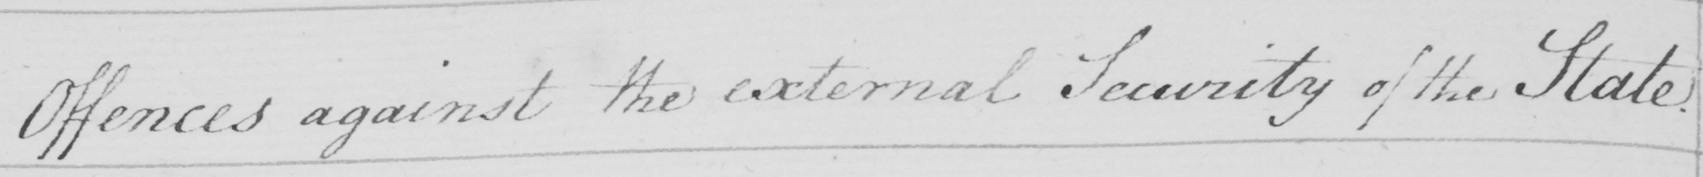Please transcribe the handwritten text in this image. Offences against the external Security of the State . 